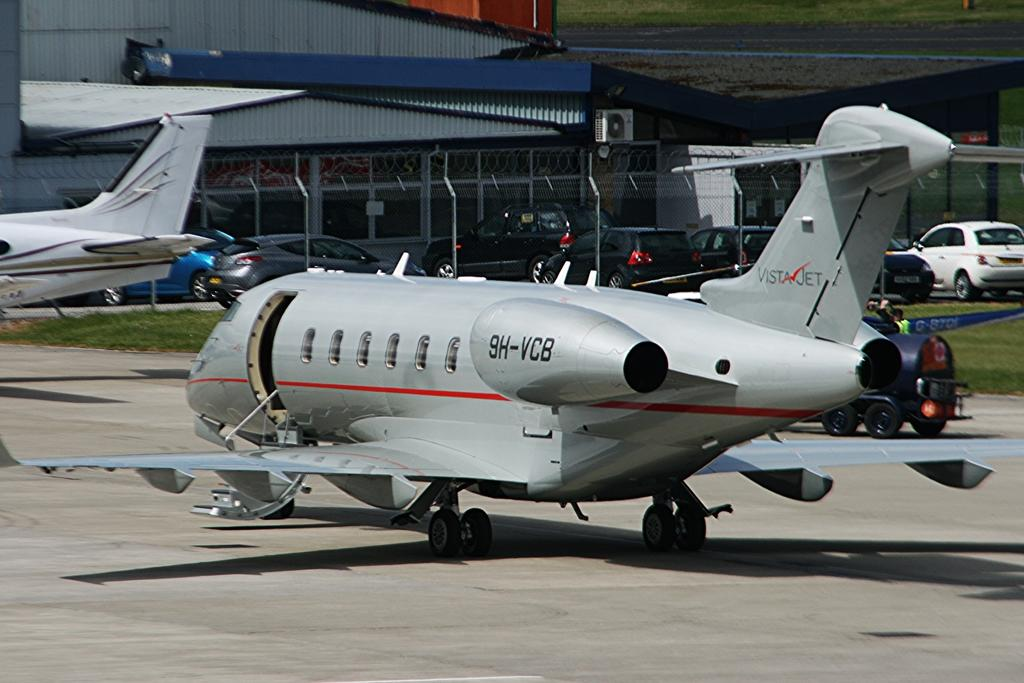Provide a one-sentence caption for the provided image. A plane that says VistaJet on the tail. 